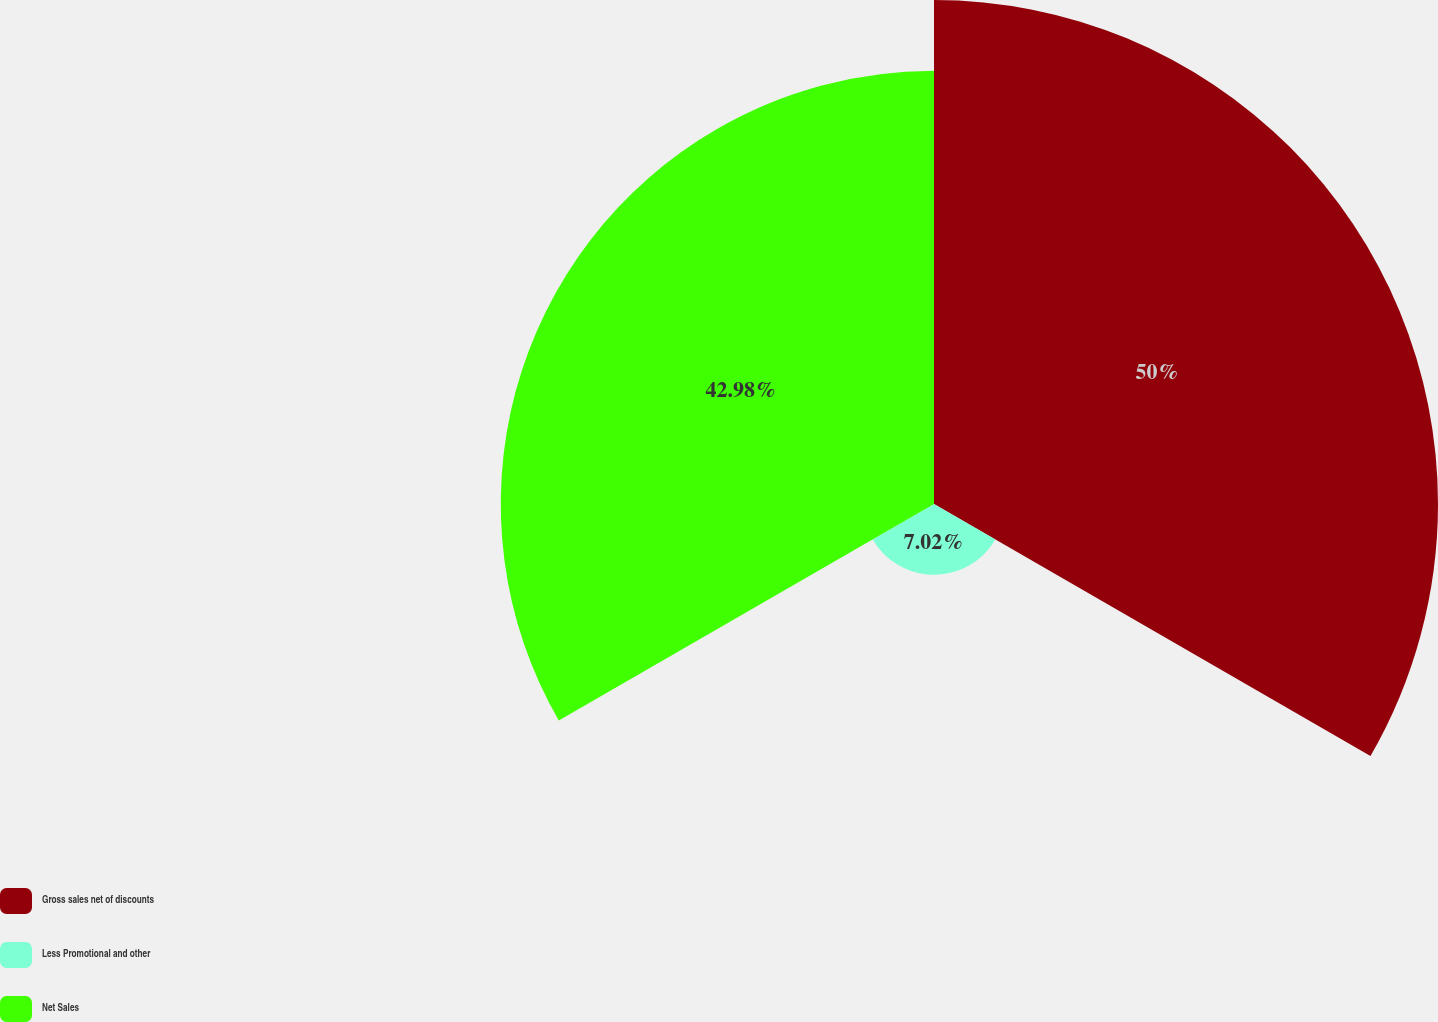Convert chart to OTSL. <chart><loc_0><loc_0><loc_500><loc_500><pie_chart><fcel>Gross sales net of discounts<fcel>Less Promotional and other<fcel>Net Sales<nl><fcel>50.0%<fcel>7.02%<fcel>42.98%<nl></chart> 